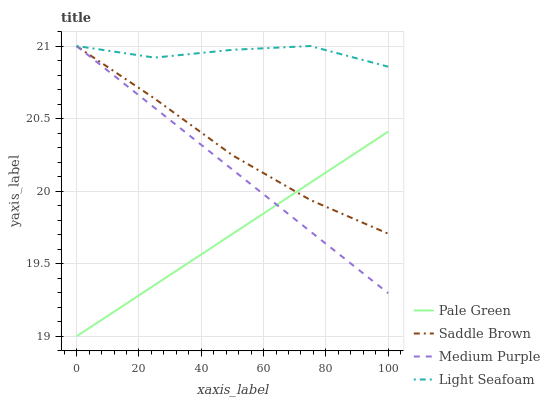Does Pale Green have the minimum area under the curve?
Answer yes or no. Yes. Does Light Seafoam have the maximum area under the curve?
Answer yes or no. Yes. Does Saddle Brown have the minimum area under the curve?
Answer yes or no. No. Does Saddle Brown have the maximum area under the curve?
Answer yes or no. No. Is Pale Green the smoothest?
Answer yes or no. Yes. Is Light Seafoam the roughest?
Answer yes or no. Yes. Is Saddle Brown the smoothest?
Answer yes or no. No. Is Saddle Brown the roughest?
Answer yes or no. No. Does Pale Green have the lowest value?
Answer yes or no. Yes. Does Saddle Brown have the lowest value?
Answer yes or no. No. Does Light Seafoam have the highest value?
Answer yes or no. Yes. Does Saddle Brown have the highest value?
Answer yes or no. No. Is Saddle Brown less than Light Seafoam?
Answer yes or no. Yes. Is Light Seafoam greater than Pale Green?
Answer yes or no. Yes. Does Medium Purple intersect Light Seafoam?
Answer yes or no. Yes. Is Medium Purple less than Light Seafoam?
Answer yes or no. No. Is Medium Purple greater than Light Seafoam?
Answer yes or no. No. Does Saddle Brown intersect Light Seafoam?
Answer yes or no. No. 